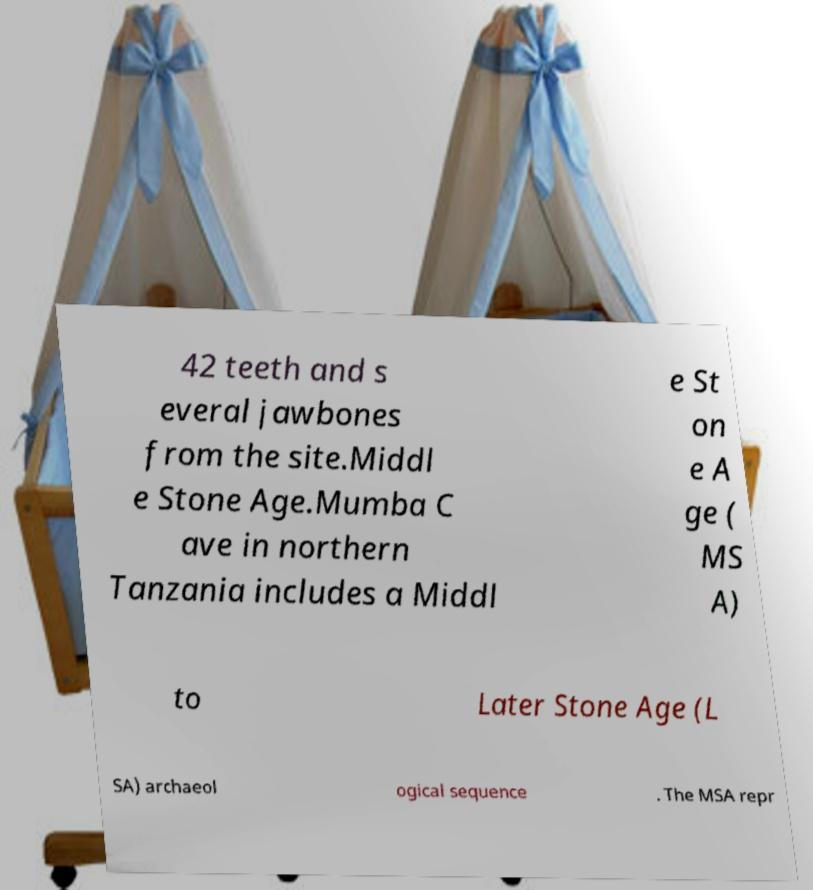Could you extract and type out the text from this image? 42 teeth and s everal jawbones from the site.Middl e Stone Age.Mumba C ave in northern Tanzania includes a Middl e St on e A ge ( MS A) to Later Stone Age (L SA) archaeol ogical sequence . The MSA repr 